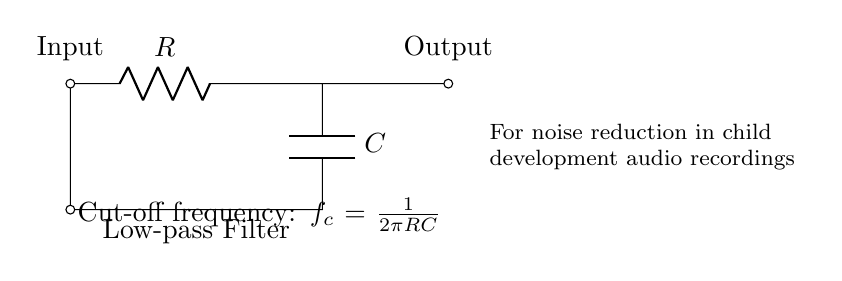What type of filter is shown in the circuit? The circuit is a low-pass filter, which allows signals with a frequency lower than a specified cut-off frequency to pass through while attenuating frequencies higher than that threshold. This distinction can be made by identifying the labeled components and understanding their purpose.
Answer: Low-pass filter What are the two main components used in this circuit? The circuit contains a resistor and a capacitor, which are crucial for the operation of a low-pass filter. The purpose of the resistor is to limit the current, while the capacitor stores and releases energy, contributing to the frequency response of the circuit.
Answer: Resistor and capacitor What is the function of the capacitor in this circuit? The capacitor in a low-pass filter charges and discharges depending on the frequency of the input signal. This behavior allows it to smooth out high-frequency signals, effectively reducing noise while allowing low-frequency signals, such as voice recordings for child development, to pass.
Answer: Reduce noise What is the cut-off frequency formula for this filter? The cut-off frequency formula is given as fc = 1 / (2πRC), where R is the resistance and C is the capacitance. This formula is derived by analyzing the impedance of the components at different frequencies and identifying the frequency where the output voltage is reduced to 70.7% of the maximum value.
Answer: f_c = 1 / 2πRC How does increasing the resistance affect the cut-off frequency? Increasing the resistance in the circuit will lead to a lower cut-off frequency, as indicated by the formula. This means that the filter will allow fewer higher-frequency signals to pass, resulting in greater noise reduction. In essence, a higher resistance results in a slower charge time for the capacitor, therefore shifting the cut-off point lower.
Answer: Lower cut-off frequency What is indicated by the output labeled in the circuit? The output labeled in the circuit represents the processed audio signal after passing through the low-pass filter. The output reflects the reduced noise from the input, which is essential for ensuring clearer and more intelligible recordings related to child development studies.
Answer: Processed audio signal 